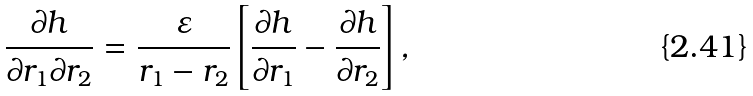Convert formula to latex. <formula><loc_0><loc_0><loc_500><loc_500>\frac { \partial h } { \partial r _ { 1 } \partial r _ { 2 } } = \frac { \varepsilon } { r _ { 1 } - r _ { 2 } } \left [ \frac { \partial h } { \partial r _ { 1 } } - \frac { \partial h } { \partial r _ { 2 } } \right ] ,</formula> 